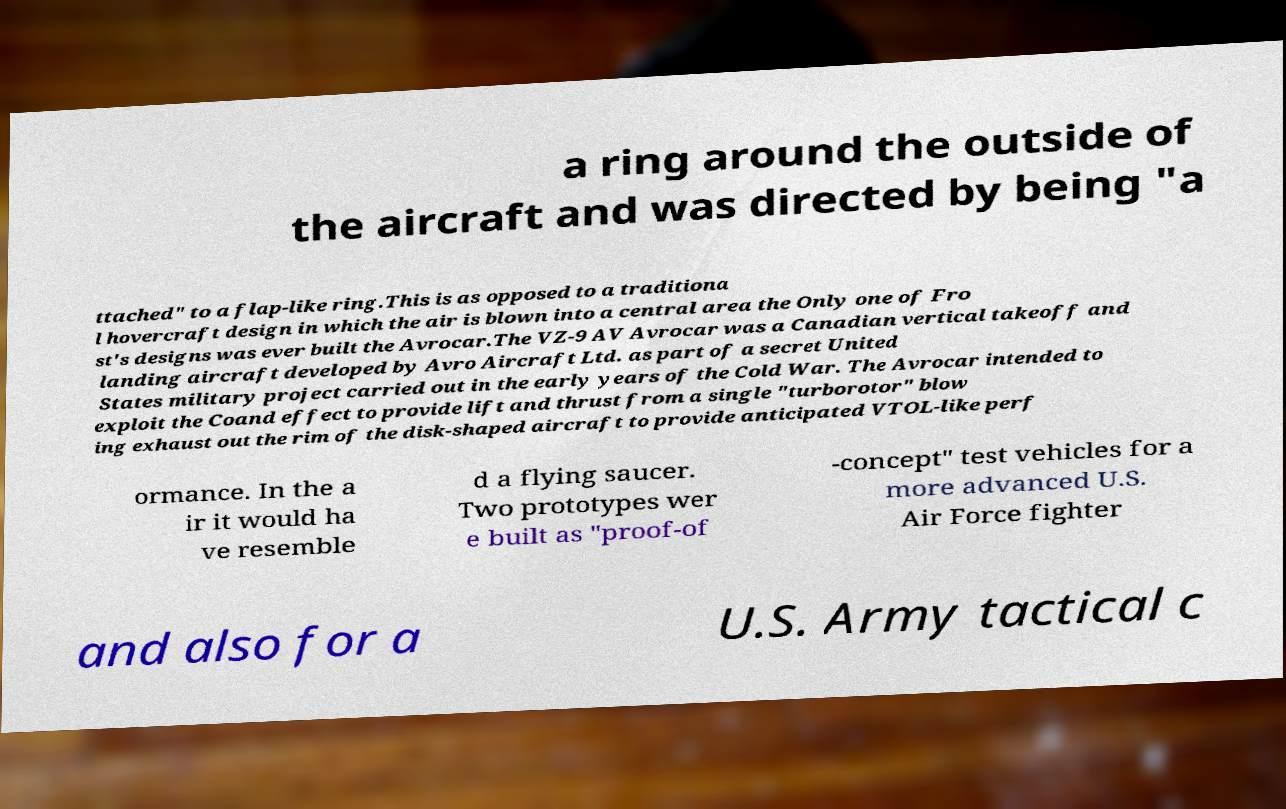There's text embedded in this image that I need extracted. Can you transcribe it verbatim? a ring around the outside of the aircraft and was directed by being "a ttached" to a flap-like ring.This is as opposed to a traditiona l hovercraft design in which the air is blown into a central area the Only one of Fro st's designs was ever built the Avrocar.The VZ-9 AV Avrocar was a Canadian vertical takeoff and landing aircraft developed by Avro Aircraft Ltd. as part of a secret United States military project carried out in the early years of the Cold War. The Avrocar intended to exploit the Coand effect to provide lift and thrust from a single "turborotor" blow ing exhaust out the rim of the disk-shaped aircraft to provide anticipated VTOL-like perf ormance. In the a ir it would ha ve resemble d a flying saucer. Two prototypes wer e built as "proof-of -concept" test vehicles for a more advanced U.S. Air Force fighter and also for a U.S. Army tactical c 